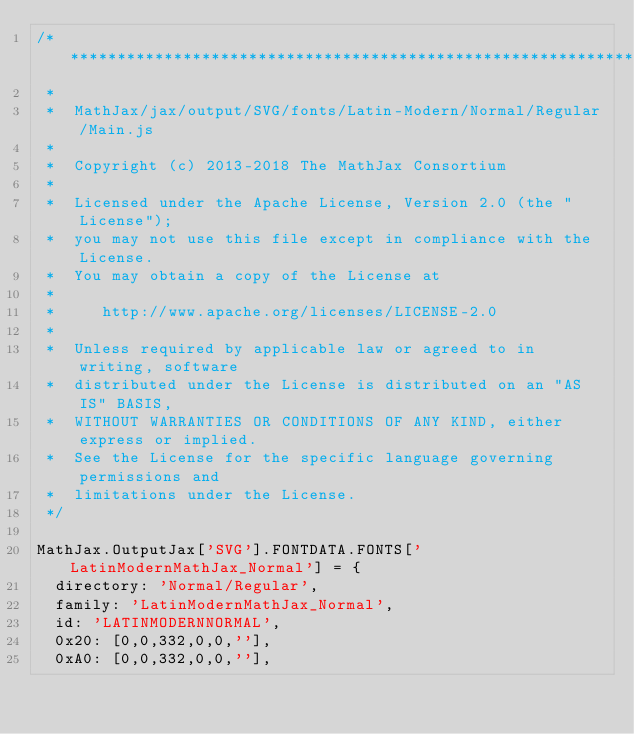<code> <loc_0><loc_0><loc_500><loc_500><_JavaScript_>/*************************************************************
 *
 *  MathJax/jax/output/SVG/fonts/Latin-Modern/Normal/Regular/Main.js
 *  
 *  Copyright (c) 2013-2018 The MathJax Consortium
 *
 *  Licensed under the Apache License, Version 2.0 (the "License");
 *  you may not use this file except in compliance with the License.
 *  You may obtain a copy of the License at
 *
 *     http://www.apache.org/licenses/LICENSE-2.0
 *
 *  Unless required by applicable law or agreed to in writing, software
 *  distributed under the License is distributed on an "AS IS" BASIS,
 *  WITHOUT WARRANTIES OR CONDITIONS OF ANY KIND, either express or implied.
 *  See the License for the specific language governing permissions and
 *  limitations under the License.
 */

MathJax.OutputJax['SVG'].FONTDATA.FONTS['LatinModernMathJax_Normal'] = {
  directory: 'Normal/Regular',
  family: 'LatinModernMathJax_Normal',
  id: 'LATINMODERNNORMAL',
  0x20: [0,0,332,0,0,''],
  0xA0: [0,0,332,0,0,''],</code> 